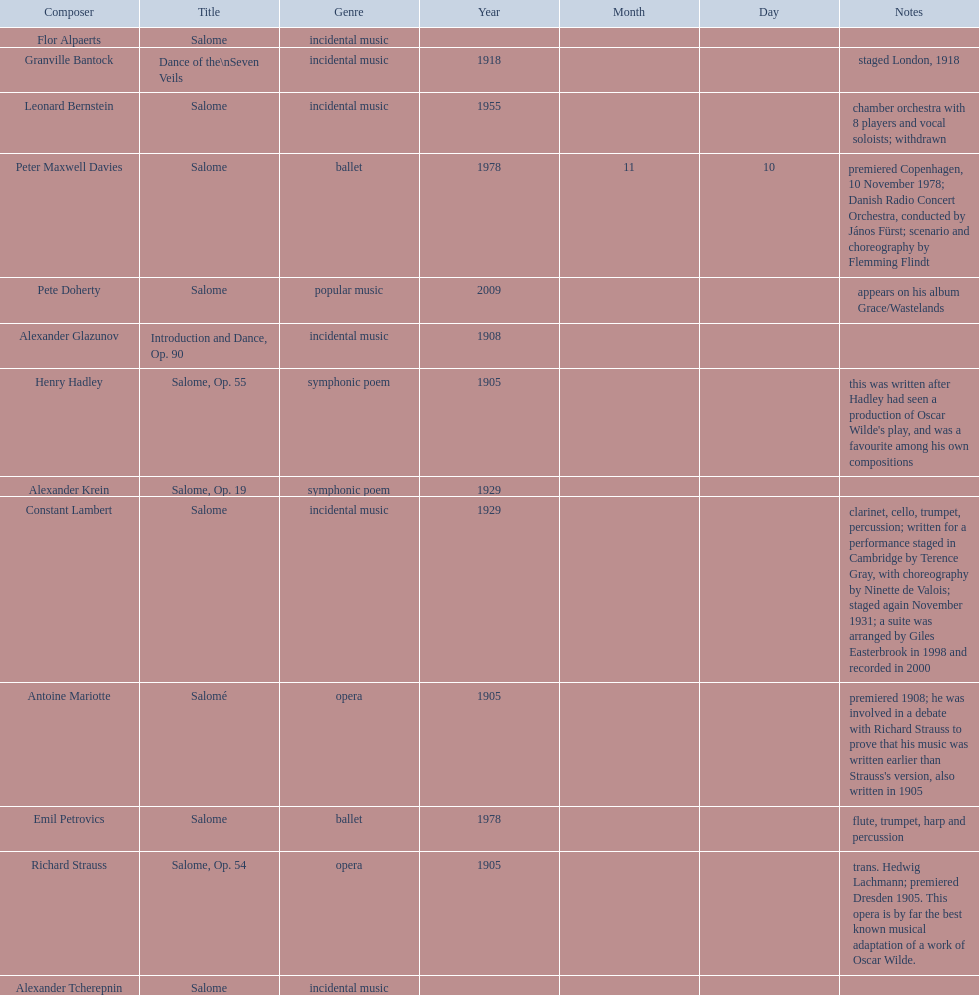Which composer produced his title after 2001? Pete Doherty. Give me the full table as a dictionary. {'header': ['Composer', 'Title', 'Genre', 'Year', 'Month', 'Day', 'Notes'], 'rows': [['Flor Alpaerts', 'Salome', 'incidental\xa0music', '', '', '', ''], ['Granville Bantock', 'Dance of the\\nSeven Veils', 'incidental music', '1918', '', '', 'staged London, 1918'], ['Leonard Bernstein', 'Salome', 'incidental music', '1955', '', '', 'chamber orchestra with 8 players and vocal soloists; withdrawn'], ['Peter\xa0Maxwell\xa0Davies', 'Salome', 'ballet', '1978', '11', '10', 'premiered Copenhagen, 10 November 1978; Danish Radio Concert Orchestra, conducted by János Fürst; scenario and choreography by Flemming Flindt'], ['Pete Doherty', 'Salome', 'popular music', '2009', '', '', 'appears on his album Grace/Wastelands'], ['Alexander Glazunov', 'Introduction and Dance, Op. 90', 'incidental music', '1908', '', '', ''], ['Henry Hadley', 'Salome, Op. 55', 'symphonic poem', '1905', '', '', "this was written after Hadley had seen a production of Oscar Wilde's play, and was a favourite among his own compositions"], ['Alexander Krein', 'Salome, Op. 19', 'symphonic poem', '1929', '', '', ''], ['Constant Lambert', 'Salome', 'incidental music', '1929', '', '', 'clarinet, cello, trumpet, percussion; written for a performance staged in Cambridge by Terence Gray, with choreography by Ninette de Valois; staged again November 1931; a suite was arranged by Giles Easterbrook in 1998 and recorded in 2000'], ['Antoine Mariotte', 'Salomé', 'opera', '1905', '', '', "premiered 1908; he was involved in a debate with Richard Strauss to prove that his music was written earlier than Strauss's version, also written in 1905"], ['Emil Petrovics', 'Salome', 'ballet', '1978', '', '', 'flute, trumpet, harp and percussion'], ['Richard Strauss', 'Salome, Op. 54', 'opera', '1905', '', '', 'trans. Hedwig Lachmann; premiered Dresden 1905. This opera is by far the best known musical adaptation of a work of Oscar Wilde.'], ['Alexander\xa0Tcherepnin', 'Salome', 'incidental music', '', '', '', '']]} 